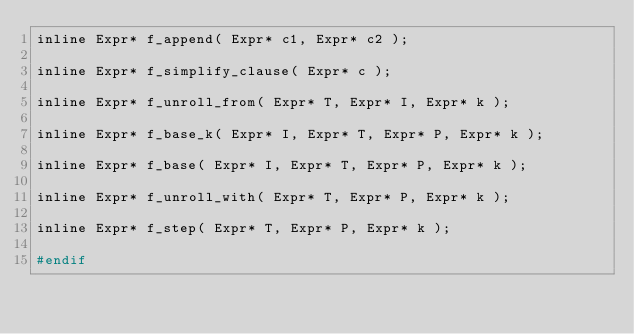Convert code to text. <code><loc_0><loc_0><loc_500><loc_500><_C_>inline Expr* f_append( Expr* c1, Expr* c2 );

inline Expr* f_simplify_clause( Expr* c );

inline Expr* f_unroll_from( Expr* T, Expr* I, Expr* k );

inline Expr* f_base_k( Expr* I, Expr* T, Expr* P, Expr* k );

inline Expr* f_base( Expr* I, Expr* T, Expr* P, Expr* k );

inline Expr* f_unroll_with( Expr* T, Expr* P, Expr* k );

inline Expr* f_step( Expr* T, Expr* P, Expr* k );

#endif

</code> 